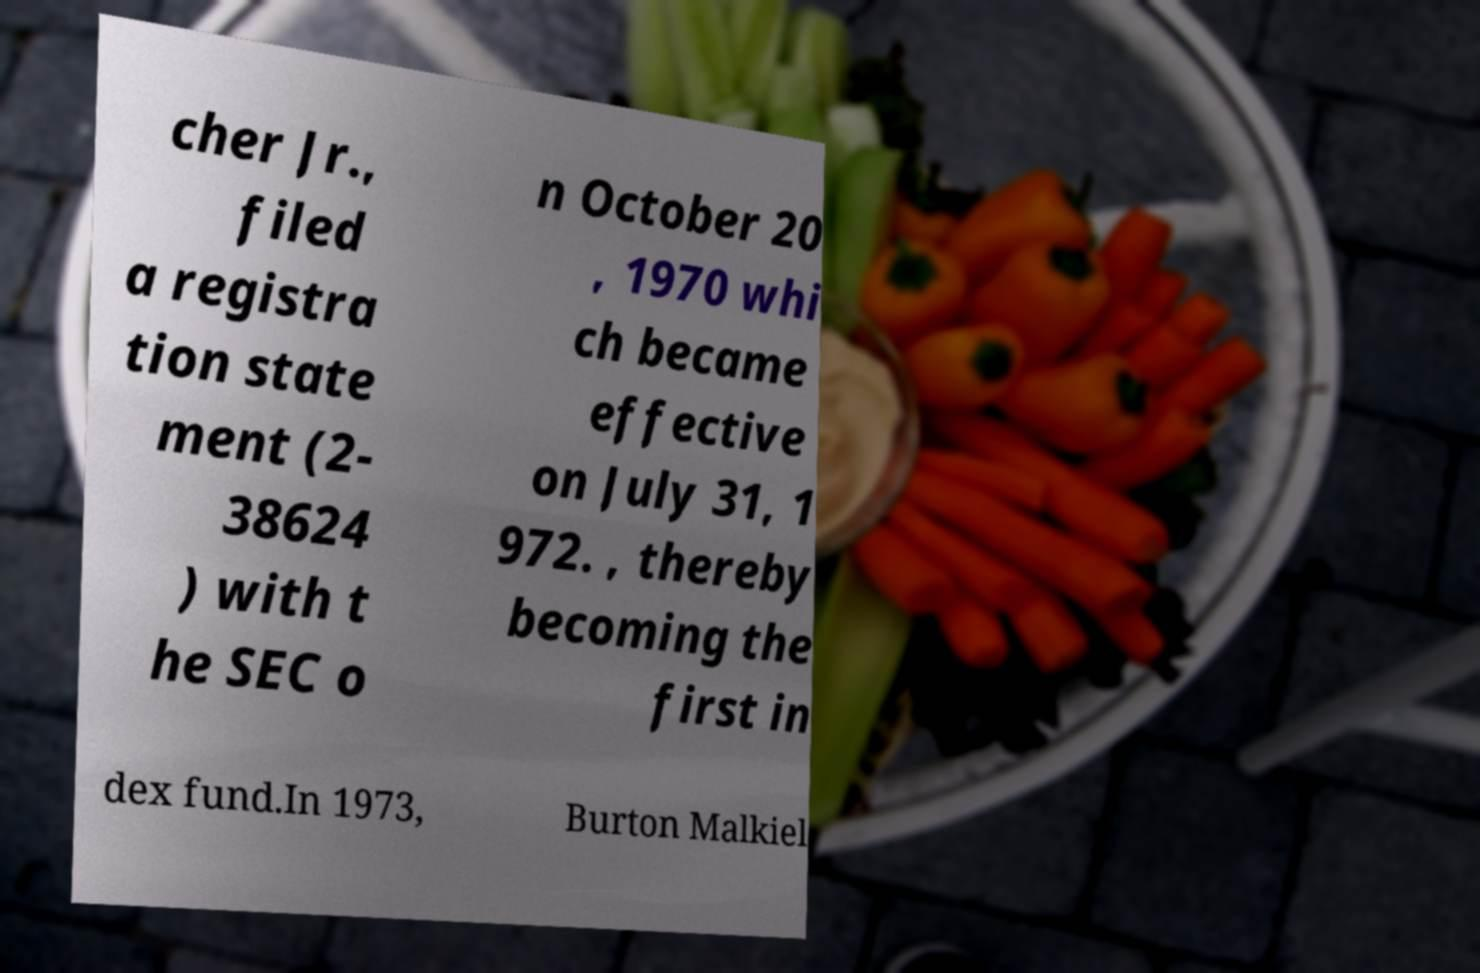Please identify and transcribe the text found in this image. cher Jr., filed a registra tion state ment (2- 38624 ) with t he SEC o n October 20 , 1970 whi ch became effective on July 31, 1 972. , thereby becoming the first in dex fund.In 1973, Burton Malkiel 